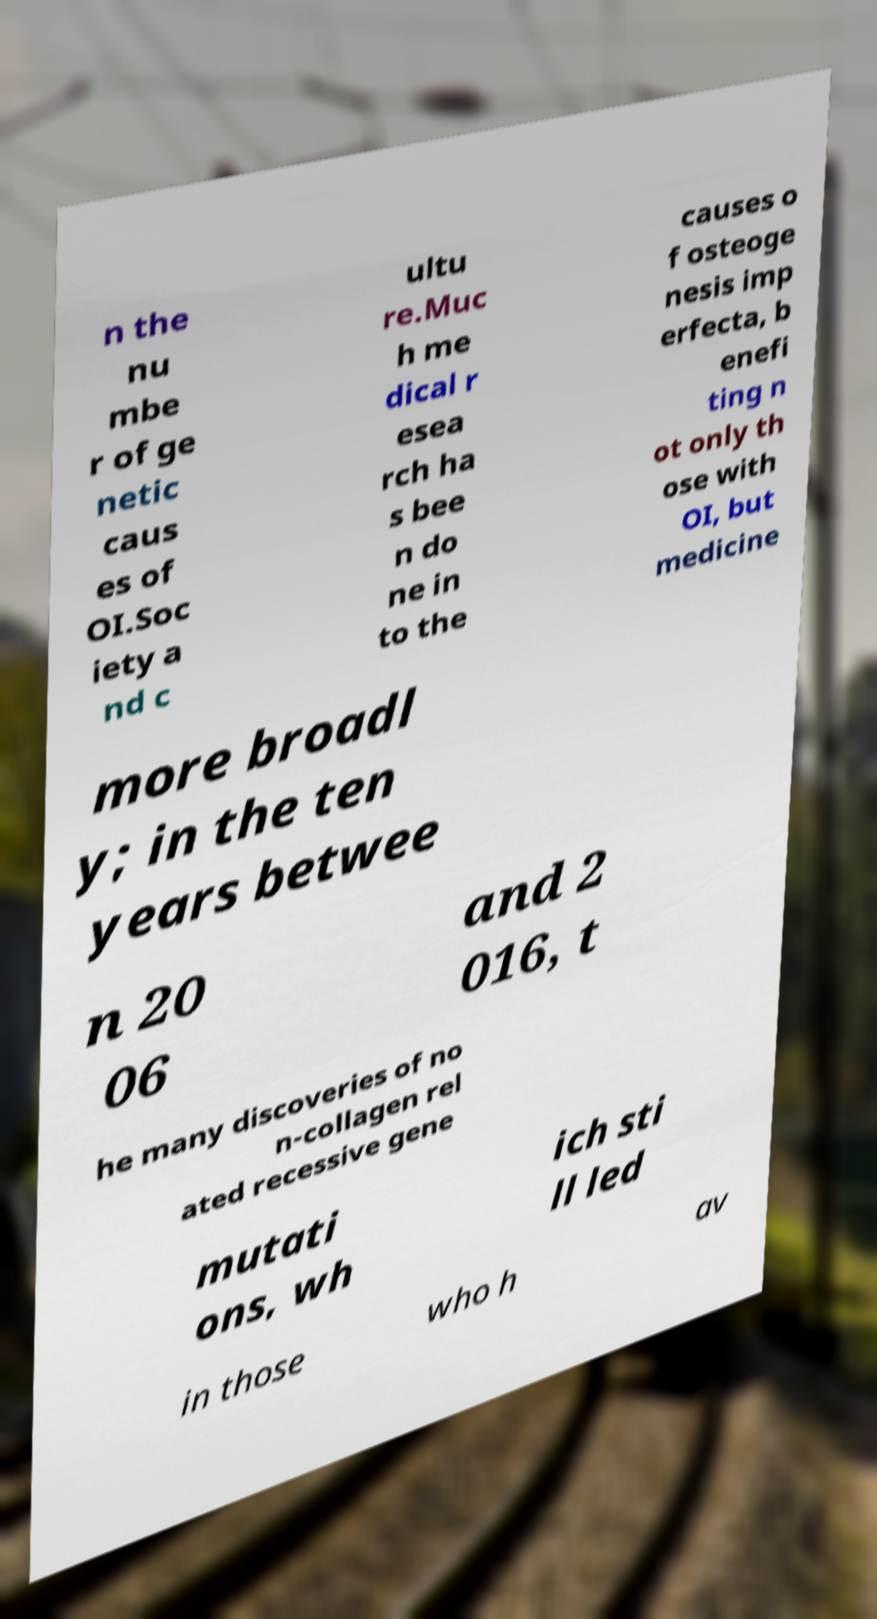For documentation purposes, I need the text within this image transcribed. Could you provide that? n the nu mbe r of ge netic caus es of OI.Soc iety a nd c ultu re.Muc h me dical r esea rch ha s bee n do ne in to the causes o f osteoge nesis imp erfecta, b enefi ting n ot only th ose with OI, but medicine more broadl y; in the ten years betwee n 20 06 and 2 016, t he many discoveries of no n-collagen rel ated recessive gene mutati ons, wh ich sti ll led in those who h av 